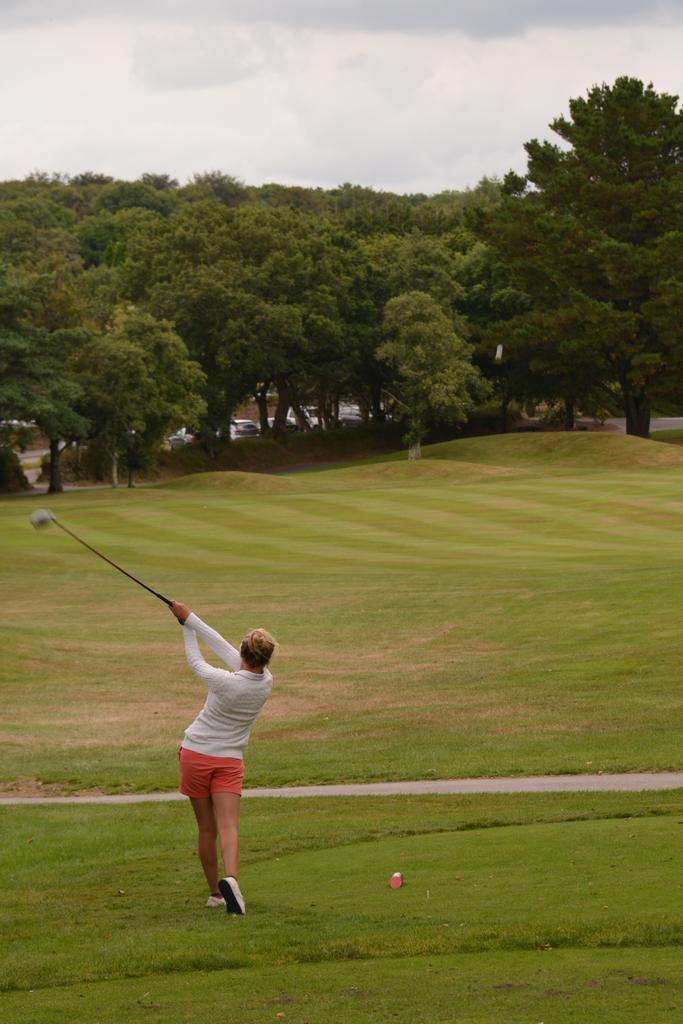In one or two sentences, can you explain what this image depicts? In this picture we can see a person is standing and holding a golf club, at the bottom there is grass, in the background we can see trees and cars, there is the sky at the top of the picture. 